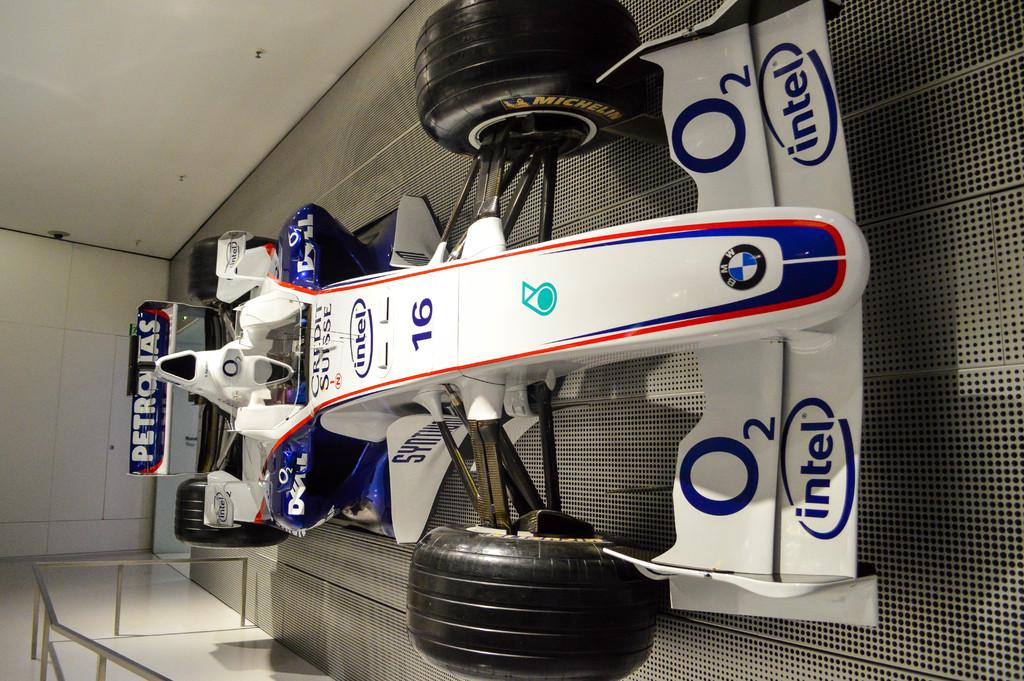What is the main subject of the image? The main subject of the image is a racing car. What colors are used to paint the racing car? The racing car is white and blue in color. Are there any markings or identifiers on the racing car? Yes, there is text and numbers written on the racing car. What can be seen at the bottom left of the image? There is railing on the wall at the bottom left of the image. What type of pest can be seen crawling on the racing car in the image? There are no pests visible on the racing car in the image. Is there a gate present in the image? No, there is no gate present in the image. 